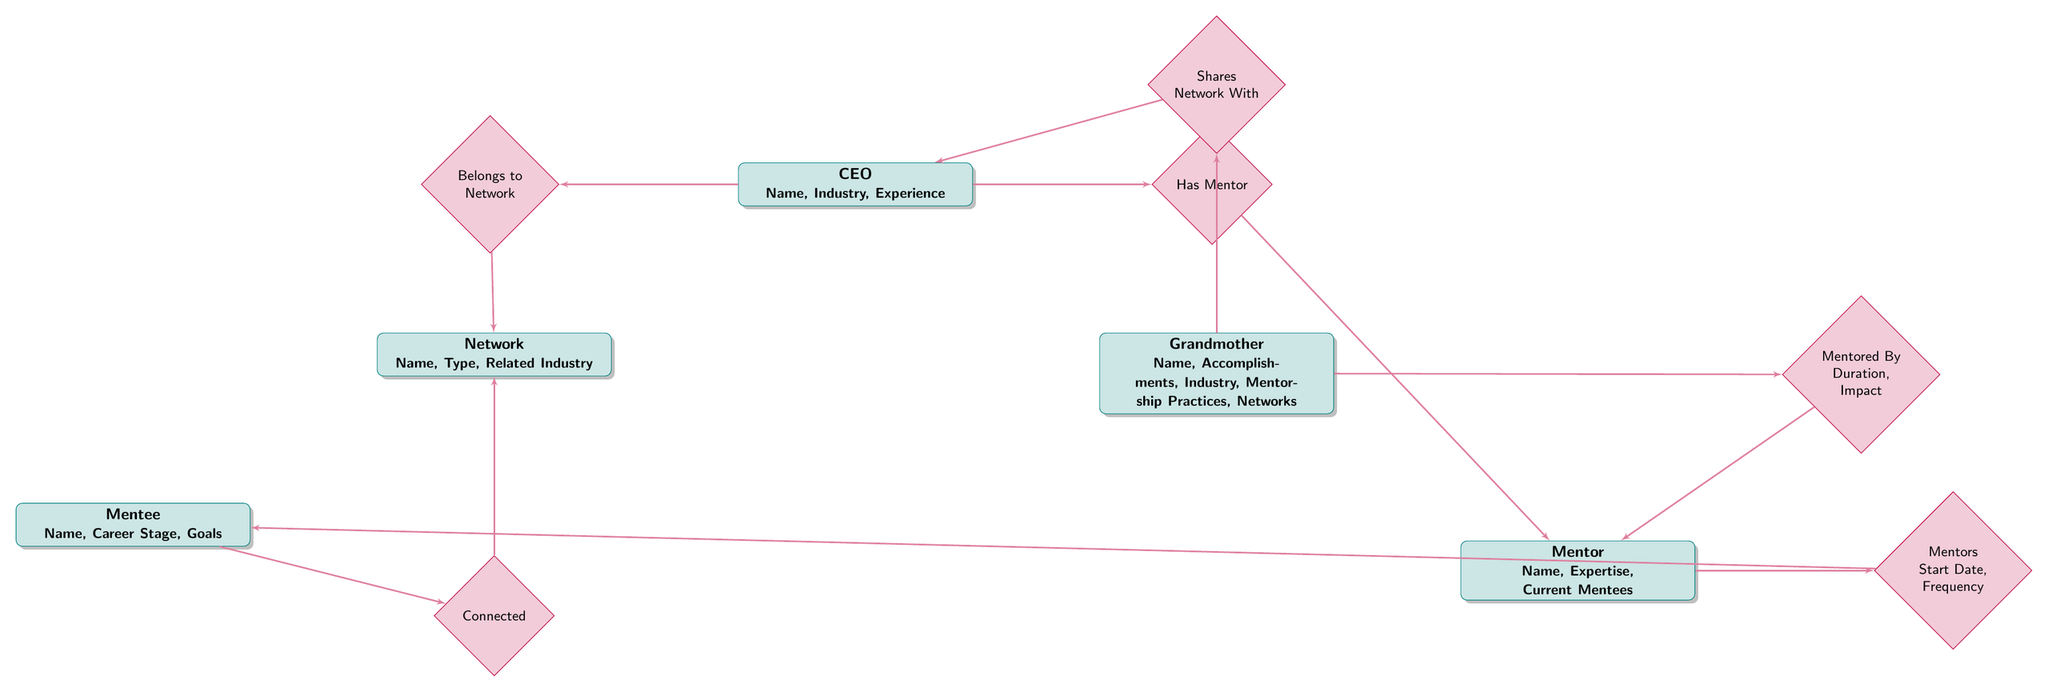What are the attributes of the CEO entity? The CEO entity has three attributes: Name, Industry, and Experience. This information is directly indicated under the "CEO" node in the diagram.
Answer: Name, Industry, Experience Which entity is connected to the Mentee? The "Mentee" entity has a direct relationship with the "Network" entity through the "Connected" relationship. This is shown by the line connecting them in the diagram.
Answer: Network How many attributes does the Grandmother entity have? The Grandmother entity has five attributes: Name, Accomplishments, Industry, Mentorship Practices, and Networks. This can be easily counted from the listed attributes under the Grandmother node in the diagram.
Answer: 5 What is the relationship type between Mentor and Mentee? The relationship type connecting Mentor and Mentee is labeled "Mentors." It can be seen as there is a diamond labeled "Mentors" between the Mentor and Mentee entities.
Answer: Mentors Who does the CEO share a network with? According to the "Shares Network With" relationship in the diagram, the CEO shares a network with the Grandmother entity. The relationship is clearly depicted by the connecting line.
Answer: Grandmother What is the effect of the Grandmother's mentorship on the Mentor entity? The Grandmother is mentored by the Mentor entity. The relationship "Mentored By" indicates that the Grandmother has a mentorship connection with the Mentor, impacting her.
Answer: Mentor What attributes are involved in the relationship between Mentor and Mentee? The "Mentors" relationship has two specific attributes involved: Start Date and Frequency. This information is indicated under the "Mentors" diamond in the diagram.
Answer: Start Date, Frequency How many entities are included in this diagram? The diagram includes a total of five distinct entities: CEO, Grandmother, Network, Mentor, and Mentee. This can be counted directly by looking at the unique rectangles in the diagram.
Answer: 5 What is the main connection type between CEO and Network? The connection type between the CEO and Network entities is "Belongs to Network," as indicated by the diamond label that connects these two entities together.
Answer: Belongs to Network 